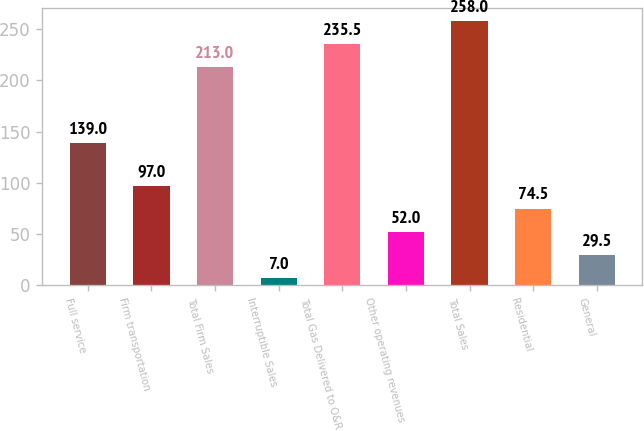Convert chart to OTSL. <chart><loc_0><loc_0><loc_500><loc_500><bar_chart><fcel>Full service<fcel>Firm transportation<fcel>Total Firm Sales<fcel>Interruptible Sales<fcel>Total Gas Delivered to O&R<fcel>Other operating revenues<fcel>Total Sales<fcel>Residential<fcel>General<nl><fcel>139<fcel>97<fcel>213<fcel>7<fcel>235.5<fcel>52<fcel>258<fcel>74.5<fcel>29.5<nl></chart> 